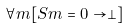<formula> <loc_0><loc_0><loc_500><loc_500>\forall m [ S m = 0 \rightarrow \perp ]</formula> 